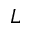Convert formula to latex. <formula><loc_0><loc_0><loc_500><loc_500>L</formula> 